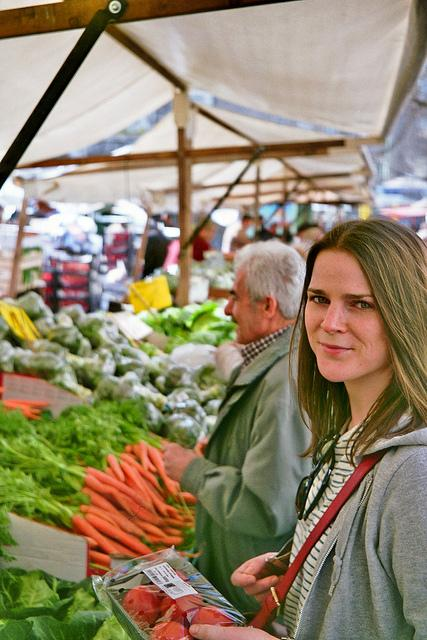Which food contains the most vitamin A? carrots 